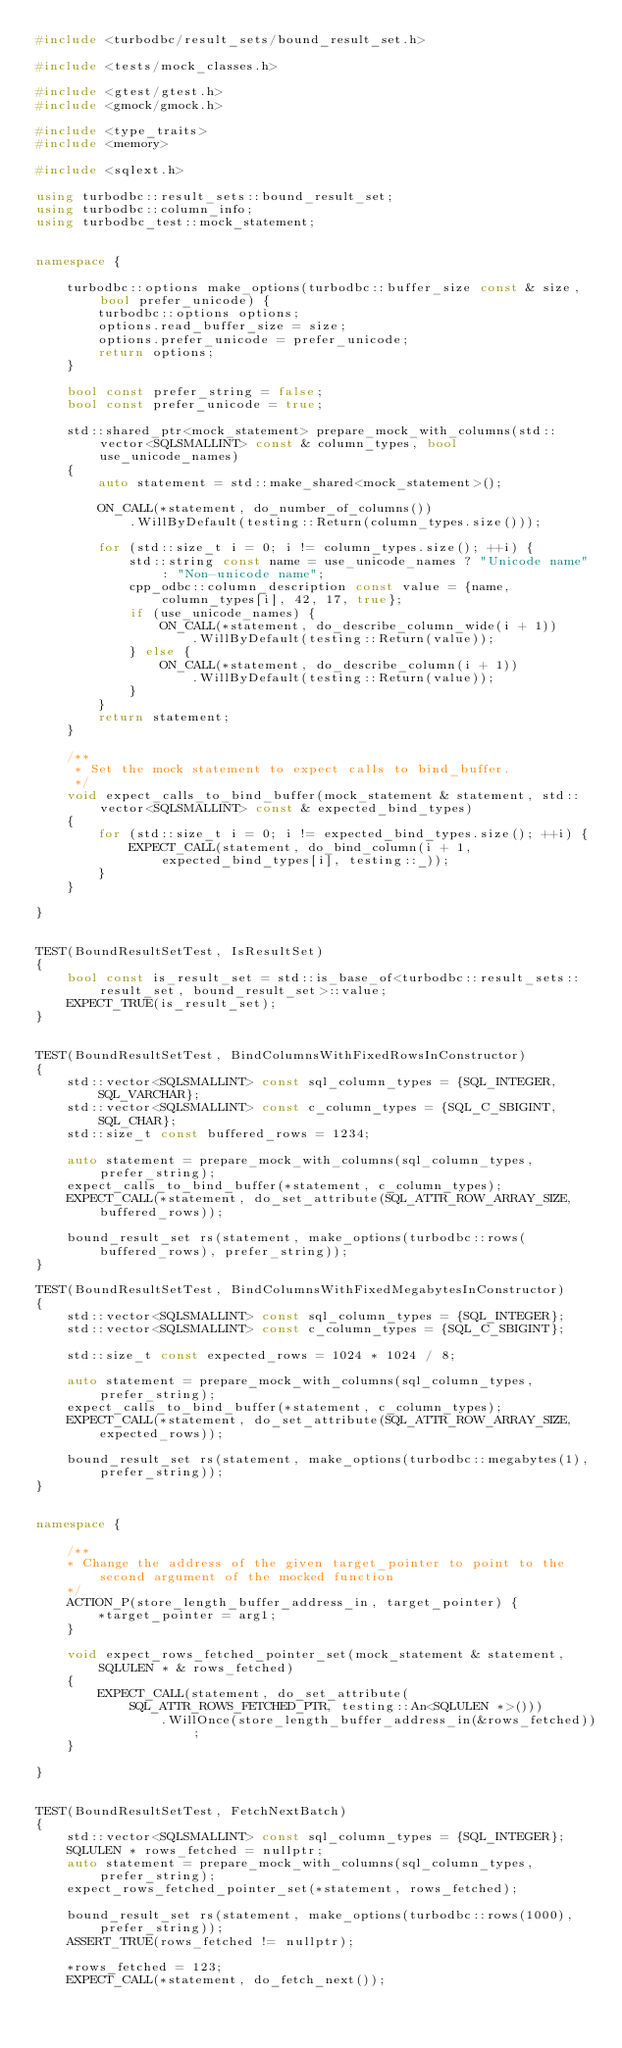<code> <loc_0><loc_0><loc_500><loc_500><_C++_>#include <turbodbc/result_sets/bound_result_set.h>

#include <tests/mock_classes.h>

#include <gtest/gtest.h>
#include <gmock/gmock.h>

#include <type_traits>
#include <memory>

#include <sqlext.h>

using turbodbc::result_sets::bound_result_set;
using turbodbc::column_info;
using turbodbc_test::mock_statement;


namespace {

    turbodbc::options make_options(turbodbc::buffer_size const & size, bool prefer_unicode) {
        turbodbc::options options;
        options.read_buffer_size = size;
        options.prefer_unicode = prefer_unicode;
        return options;
    }

    bool const prefer_string = false;
    bool const prefer_unicode = true;

    std::shared_ptr<mock_statement> prepare_mock_with_columns(std::vector<SQLSMALLINT> const & column_types, bool use_unicode_names)
    {
        auto statement = std::make_shared<mock_statement>();

        ON_CALL(*statement, do_number_of_columns())
            .WillByDefault(testing::Return(column_types.size()));

        for (std::size_t i = 0; i != column_types.size(); ++i) {
            std::string const name = use_unicode_names ? "Unicode name" : "Non-unicode name";
            cpp_odbc::column_description const value = {name, column_types[i], 42, 17, true};
            if (use_unicode_names) {
                ON_CALL(*statement, do_describe_column_wide(i + 1))
                    .WillByDefault(testing::Return(value));
            } else {
                ON_CALL(*statement, do_describe_column(i + 1))
                    .WillByDefault(testing::Return(value));
            }
        }
        return statement;
    }

    /**
     * Set the mock statement to expect calls to bind_buffer.
     */
    void expect_calls_to_bind_buffer(mock_statement & statement, std::vector<SQLSMALLINT> const & expected_bind_types)
    {
        for (std::size_t i = 0; i != expected_bind_types.size(); ++i) {
            EXPECT_CALL(statement, do_bind_column(i + 1, expected_bind_types[i], testing::_));
        }
    }

}


TEST(BoundResultSetTest, IsResultSet)
{
    bool const is_result_set = std::is_base_of<turbodbc::result_sets::result_set, bound_result_set>::value;
    EXPECT_TRUE(is_result_set);
}


TEST(BoundResultSetTest, BindColumnsWithFixedRowsInConstructor)
{
    std::vector<SQLSMALLINT> const sql_column_types = {SQL_INTEGER, SQL_VARCHAR};
    std::vector<SQLSMALLINT> const c_column_types = {SQL_C_SBIGINT, SQL_CHAR};
    std::size_t const buffered_rows = 1234;

    auto statement = prepare_mock_with_columns(sql_column_types, prefer_string);
    expect_calls_to_bind_buffer(*statement, c_column_types);
    EXPECT_CALL(*statement, do_set_attribute(SQL_ATTR_ROW_ARRAY_SIZE, buffered_rows));

    bound_result_set rs(statement, make_options(turbodbc::rows(buffered_rows), prefer_string));
}

TEST(BoundResultSetTest, BindColumnsWithFixedMegabytesInConstructor)
{
    std::vector<SQLSMALLINT> const sql_column_types = {SQL_INTEGER};
    std::vector<SQLSMALLINT> const c_column_types = {SQL_C_SBIGINT};

    std::size_t const expected_rows = 1024 * 1024 / 8;

    auto statement = prepare_mock_with_columns(sql_column_types, prefer_string);
    expect_calls_to_bind_buffer(*statement, c_column_types);
    EXPECT_CALL(*statement, do_set_attribute(SQL_ATTR_ROW_ARRAY_SIZE, expected_rows));

    bound_result_set rs(statement, make_options(turbodbc::megabytes(1), prefer_string));
}


namespace {

    /**
    * Change the address of the given target_pointer to point to the second argument of the mocked function
    */
    ACTION_P(store_length_buffer_address_in, target_pointer) {
        *target_pointer = arg1;
    }

    void expect_rows_fetched_pointer_set(mock_statement & statement, SQLULEN * & rows_fetched)
    {
        EXPECT_CALL(statement, do_set_attribute(SQL_ATTR_ROWS_FETCHED_PTR, testing::An<SQLULEN *>()))
                .WillOnce(store_length_buffer_address_in(&rows_fetched));
    }

}


TEST(BoundResultSetTest, FetchNextBatch)
{
    std::vector<SQLSMALLINT> const sql_column_types = {SQL_INTEGER};
    SQLULEN * rows_fetched = nullptr;
    auto statement = prepare_mock_with_columns(sql_column_types, prefer_string);
    expect_rows_fetched_pointer_set(*statement, rows_fetched);

    bound_result_set rs(statement, make_options(turbodbc::rows(1000), prefer_string));
    ASSERT_TRUE(rows_fetched != nullptr);

    *rows_fetched = 123;
    EXPECT_CALL(*statement, do_fetch_next());
</code> 